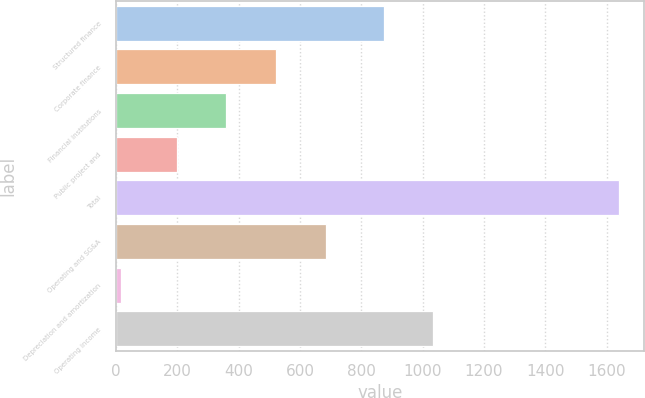Convert chart. <chart><loc_0><loc_0><loc_500><loc_500><bar_chart><fcel>Structured finance<fcel>Corporate finance<fcel>Financial institutions<fcel>Public project and<fcel>Total<fcel>Operating and SG&A<fcel>Depreciation and amortization<fcel>Operating income<nl><fcel>872.6<fcel>522.7<fcel>360.45<fcel>198.2<fcel>1639.8<fcel>684.95<fcel>17.3<fcel>1034.85<nl></chart> 